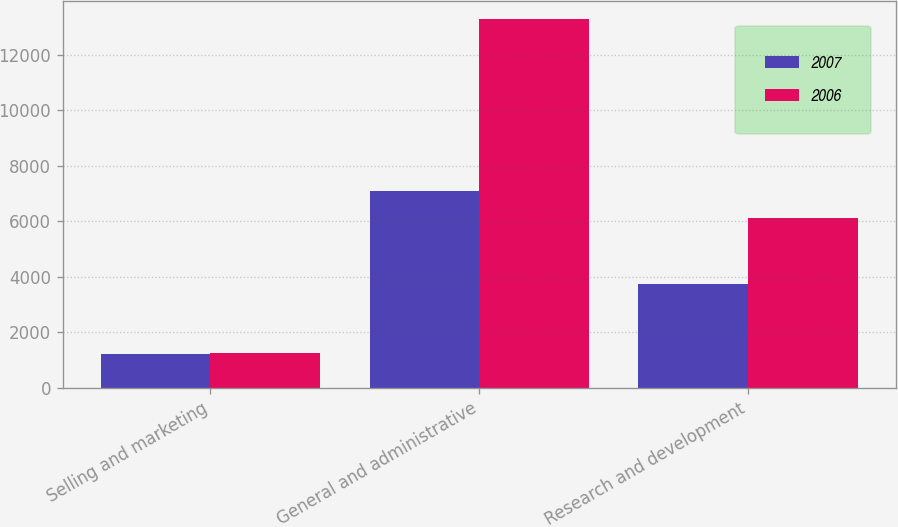<chart> <loc_0><loc_0><loc_500><loc_500><stacked_bar_chart><ecel><fcel>Selling and marketing<fcel>General and administrative<fcel>Research and development<nl><fcel>2007<fcel>1232<fcel>7080<fcel>3735<nl><fcel>2006<fcel>1256<fcel>13277<fcel>6135<nl></chart> 